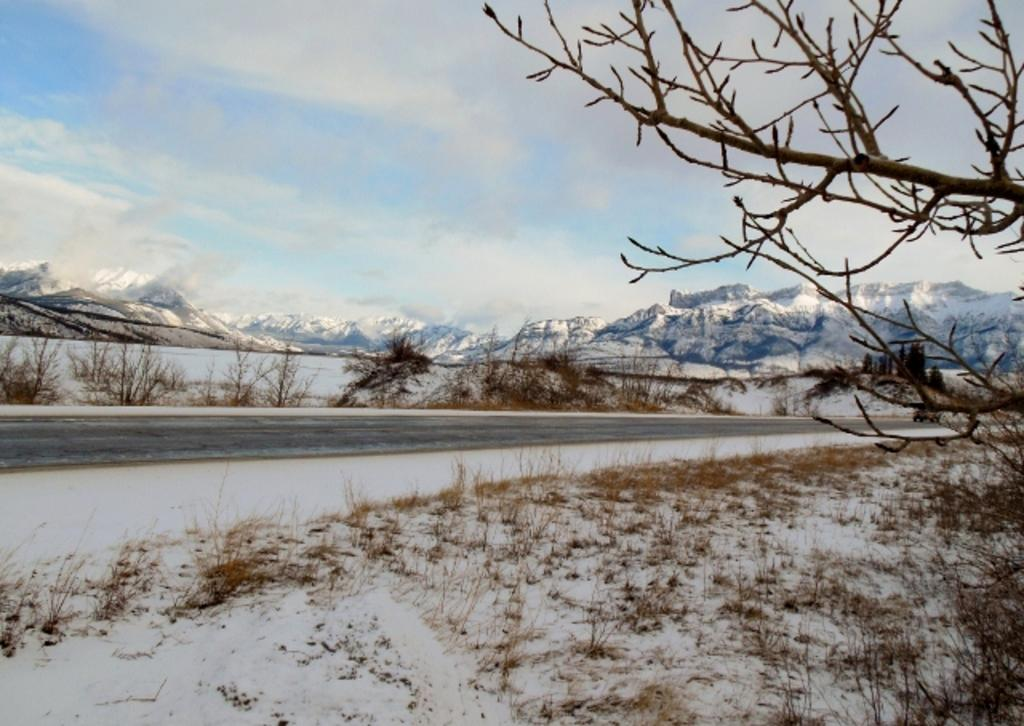What is the main feature of the image? There is a road in the image. What can be seen on either side of the road? Snow is present on either side of the road. What is visible in the background of the image? There are mountains in the background of the image. How are the mountains affected by the weather? The mountains are covered with snow. How many boats are visible in the image? There are no boats present in the image. What degree of difficulty is the question about the mountains in the image? The question about the mountains in the image does not have a degree of difficulty, as it is a simple observation based on the provided facts. 